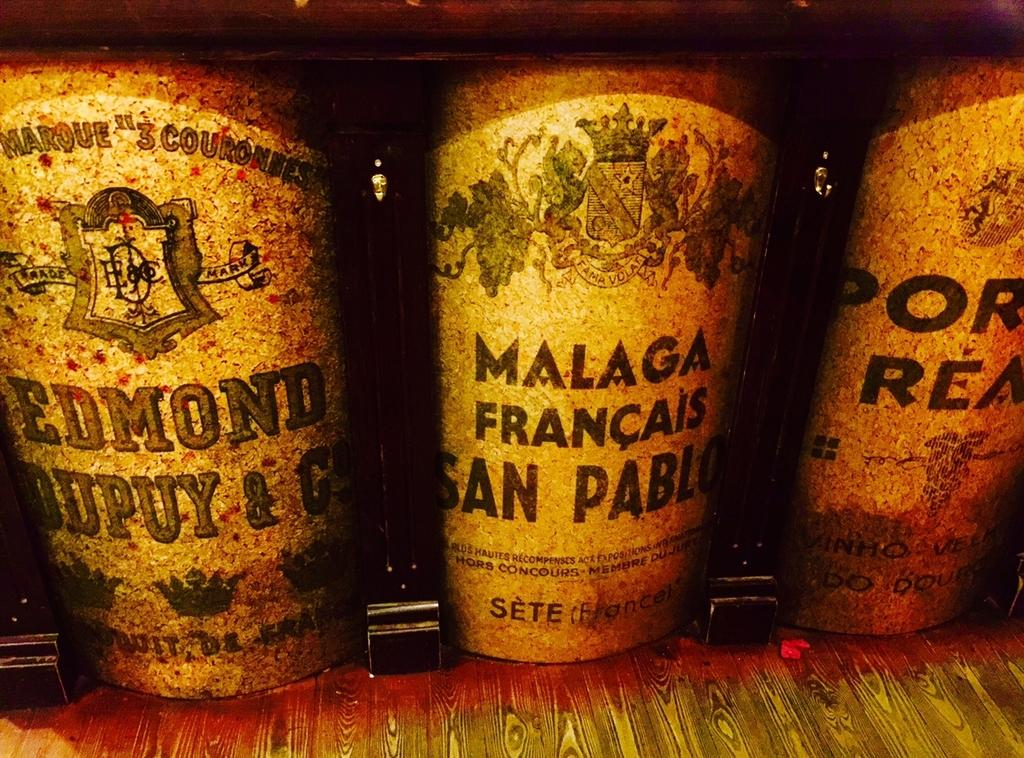<image>
Describe the image concisely. Three old and weathered containers with French writing on them. 